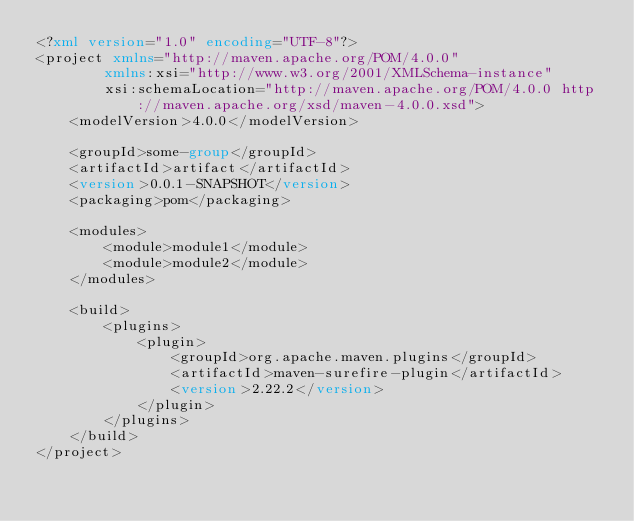Convert code to text. <code><loc_0><loc_0><loc_500><loc_500><_XML_><?xml version="1.0" encoding="UTF-8"?>
<project xmlns="http://maven.apache.org/POM/4.0.0"
        xmlns:xsi="http://www.w3.org/2001/XMLSchema-instance"
        xsi:schemaLocation="http://maven.apache.org/POM/4.0.0 http://maven.apache.org/xsd/maven-4.0.0.xsd">
    <modelVersion>4.0.0</modelVersion>

    <groupId>some-group</groupId>
    <artifactId>artifact</artifactId>
    <version>0.0.1-SNAPSHOT</version>
    <packaging>pom</packaging>

    <modules>
        <module>module1</module>
        <module>module2</module>
    </modules>

    <build>
        <plugins>
            <plugin>
                <groupId>org.apache.maven.plugins</groupId>
                <artifactId>maven-surefire-plugin</artifactId>
                <version>2.22.2</version>
            </plugin>
        </plugins>
    </build>
</project>
</code> 